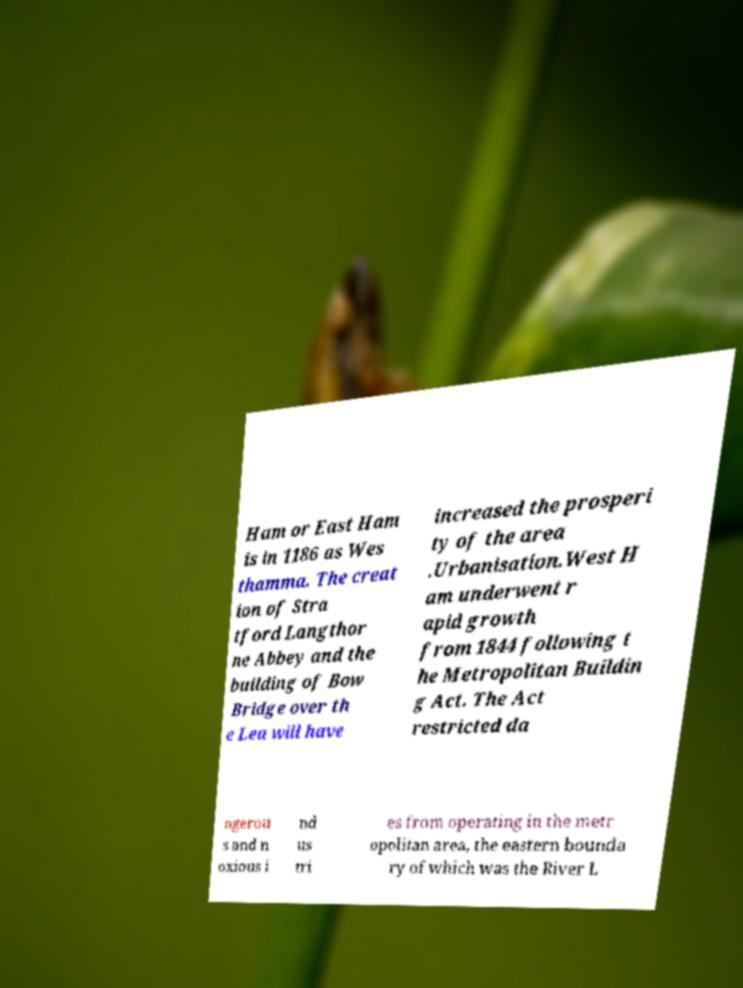Can you read and provide the text displayed in the image?This photo seems to have some interesting text. Can you extract and type it out for me? Ham or East Ham is in 1186 as Wes thamma. The creat ion of Stra tford Langthor ne Abbey and the building of Bow Bridge over th e Lea will have increased the prosperi ty of the area .Urbanisation.West H am underwent r apid growth from 1844 following t he Metropolitan Buildin g Act. The Act restricted da ngerou s and n oxious i nd us tri es from operating in the metr opolitan area, the eastern bounda ry of which was the River L 